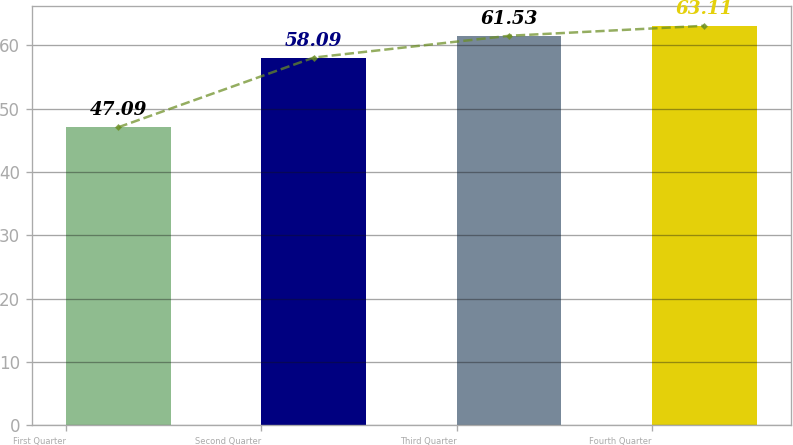<chart> <loc_0><loc_0><loc_500><loc_500><bar_chart><fcel>First Quarter<fcel>Second Quarter<fcel>Third Quarter<fcel>Fourth Quarter<nl><fcel>47.09<fcel>58.09<fcel>61.53<fcel>63.11<nl></chart> 